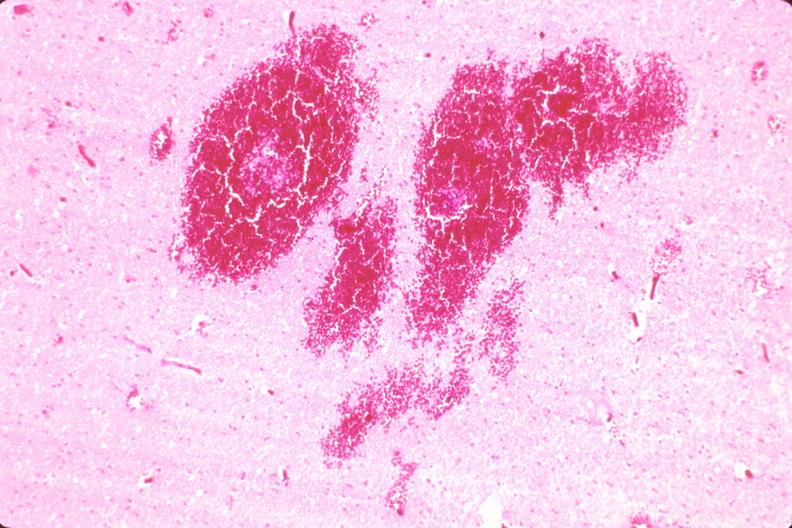where is this?
Answer the question using a single word or phrase. Nervous 